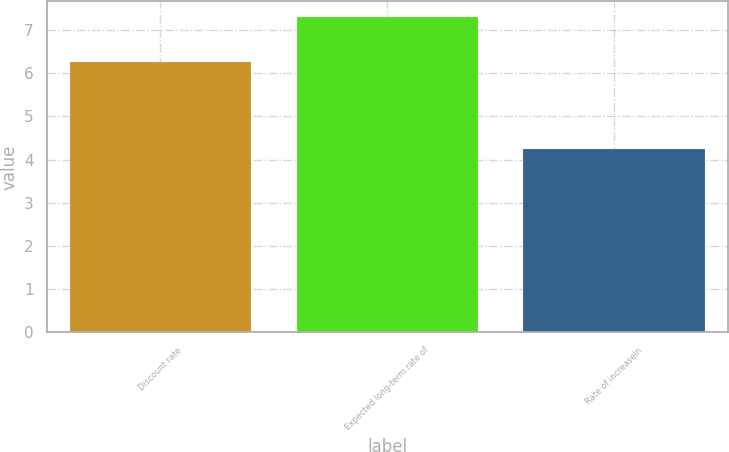<chart> <loc_0><loc_0><loc_500><loc_500><bar_chart><fcel>Discount rate<fcel>Expected long-term rate of<fcel>Rate of increasein<nl><fcel>6.25<fcel>7.3<fcel>4.25<nl></chart> 